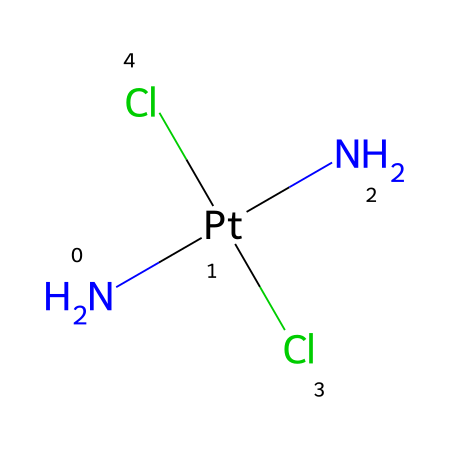What is the metal ion in this coordination complex? The structure includes a platinum atom symbolized by "Pt," indicating that platinum is the central metal ion in this coordination complex.
Answer: platinum How many chloride ligands are present in cisplatin? The SMILES representation shows two "Cl" symbols, indicating the presence of two chloride ligands attached to the platinum center in the coordinate complex.
Answer: 2 What type of ligands are present in this compound? The presence of "N" indicates the presence of amine ligands (specifically, two amine groups in this case), while "Cl" denotes chloride ligands. This combination identifies the ligands as bidentate and chloride.
Answer: amine and chloride Is cisplatin a square planar or octahedral complex? The molecular geometry of cisplatin can be determined based on its coordination number and known geometry of platinum(II) complexes, which typically adopt a square planar configuration due to spatial arrangement of the bonding pairs.
Answer: square planar What is the oxidation state of platinum in cisplatin? In the coordination complex, platinum is coordinated with two chloride ligands and two amine groups. The oxidation state can be calculated using the charge of ligands (chloride is -1 each) and the neutral ligands. Thus, the oxidation state is +2.
Answer: +2 